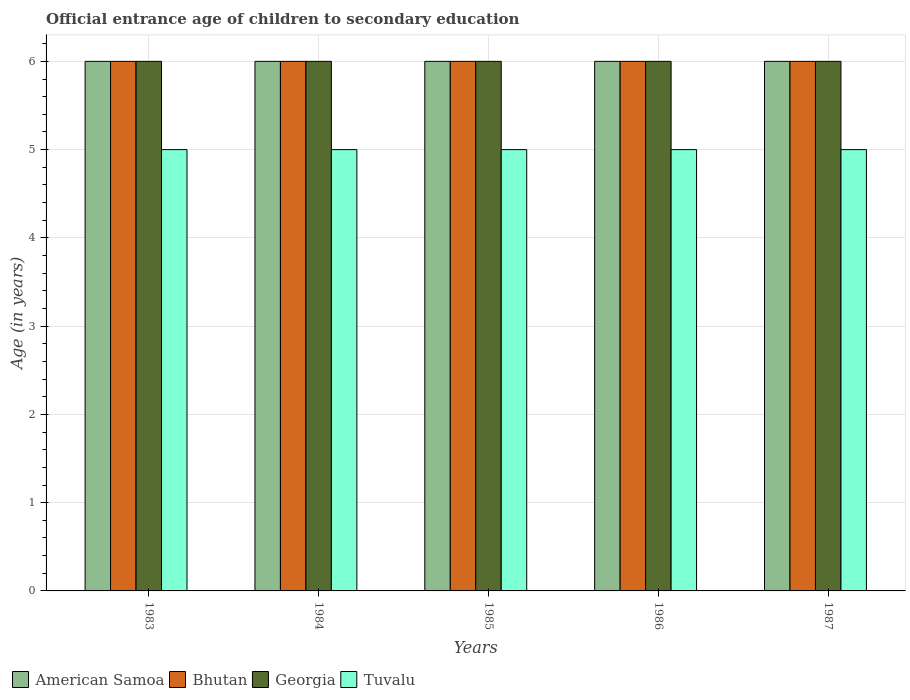How many different coloured bars are there?
Keep it short and to the point. 4. How many groups of bars are there?
Your answer should be compact. 5. What is the label of the 2nd group of bars from the left?
Provide a succinct answer. 1984. Across all years, what is the minimum secondary school starting age of children in Tuvalu?
Your response must be concise. 5. In which year was the secondary school starting age of children in Tuvalu maximum?
Your response must be concise. 1983. What is the total secondary school starting age of children in Georgia in the graph?
Provide a succinct answer. 30. What is the difference between the secondary school starting age of children in Tuvalu in 1983 and that in 1986?
Make the answer very short. 0. What is the average secondary school starting age of children in Bhutan per year?
Your answer should be very brief. 6. In the year 1985, what is the difference between the secondary school starting age of children in Bhutan and secondary school starting age of children in Tuvalu?
Keep it short and to the point. 1. In how many years, is the secondary school starting age of children in Georgia greater than 0.6000000000000001 years?
Offer a terse response. 5. What is the ratio of the secondary school starting age of children in Bhutan in 1985 to that in 1986?
Your answer should be compact. 1. What is the difference between the highest and the second highest secondary school starting age of children in American Samoa?
Your answer should be compact. 0. In how many years, is the secondary school starting age of children in Bhutan greater than the average secondary school starting age of children in Bhutan taken over all years?
Provide a short and direct response. 0. Is the sum of the secondary school starting age of children in Georgia in 1984 and 1986 greater than the maximum secondary school starting age of children in American Samoa across all years?
Your response must be concise. Yes. Is it the case that in every year, the sum of the secondary school starting age of children in American Samoa and secondary school starting age of children in Georgia is greater than the sum of secondary school starting age of children in Bhutan and secondary school starting age of children in Tuvalu?
Provide a short and direct response. Yes. What does the 2nd bar from the left in 1986 represents?
Ensure brevity in your answer.  Bhutan. What does the 1st bar from the right in 1983 represents?
Keep it short and to the point. Tuvalu. Is it the case that in every year, the sum of the secondary school starting age of children in Georgia and secondary school starting age of children in Tuvalu is greater than the secondary school starting age of children in American Samoa?
Your answer should be compact. Yes. How many bars are there?
Offer a very short reply. 20. Does the graph contain grids?
Make the answer very short. Yes. Where does the legend appear in the graph?
Make the answer very short. Bottom left. How many legend labels are there?
Make the answer very short. 4. What is the title of the graph?
Ensure brevity in your answer.  Official entrance age of children to secondary education. Does "Honduras" appear as one of the legend labels in the graph?
Provide a succinct answer. No. What is the label or title of the Y-axis?
Offer a terse response. Age (in years). What is the Age (in years) in American Samoa in 1983?
Provide a short and direct response. 6. What is the Age (in years) of Georgia in 1983?
Your answer should be compact. 6. What is the Age (in years) of Georgia in 1984?
Your response must be concise. 6. What is the Age (in years) in Tuvalu in 1984?
Provide a short and direct response. 5. What is the Age (in years) of Bhutan in 1985?
Give a very brief answer. 6. What is the Age (in years) in Georgia in 1985?
Give a very brief answer. 6. What is the Age (in years) of Bhutan in 1986?
Give a very brief answer. 6. What is the Age (in years) of Georgia in 1986?
Make the answer very short. 6. What is the Age (in years) of Tuvalu in 1986?
Give a very brief answer. 5. What is the Age (in years) in Tuvalu in 1987?
Offer a very short reply. 5. Across all years, what is the maximum Age (in years) of Bhutan?
Make the answer very short. 6. Across all years, what is the maximum Age (in years) of Tuvalu?
Ensure brevity in your answer.  5. Across all years, what is the minimum Age (in years) of Bhutan?
Make the answer very short. 6. What is the total Age (in years) of American Samoa in the graph?
Offer a terse response. 30. What is the total Age (in years) in Georgia in the graph?
Your answer should be compact. 30. What is the total Age (in years) of Tuvalu in the graph?
Your answer should be very brief. 25. What is the difference between the Age (in years) of Georgia in 1983 and that in 1984?
Provide a succinct answer. 0. What is the difference between the Age (in years) in Georgia in 1983 and that in 1985?
Your answer should be compact. 0. What is the difference between the Age (in years) in Tuvalu in 1983 and that in 1985?
Make the answer very short. 0. What is the difference between the Age (in years) in American Samoa in 1983 and that in 1986?
Make the answer very short. 0. What is the difference between the Age (in years) in Bhutan in 1983 and that in 1986?
Your answer should be very brief. 0. What is the difference between the Age (in years) of Georgia in 1983 and that in 1986?
Provide a short and direct response. 0. What is the difference between the Age (in years) in Tuvalu in 1983 and that in 1986?
Give a very brief answer. 0. What is the difference between the Age (in years) of American Samoa in 1983 and that in 1987?
Provide a short and direct response. 0. What is the difference between the Age (in years) in Georgia in 1983 and that in 1987?
Provide a succinct answer. 0. What is the difference between the Age (in years) of American Samoa in 1984 and that in 1985?
Your response must be concise. 0. What is the difference between the Age (in years) of Bhutan in 1984 and that in 1985?
Provide a succinct answer. 0. What is the difference between the Age (in years) of Georgia in 1984 and that in 1985?
Provide a short and direct response. 0. What is the difference between the Age (in years) in American Samoa in 1984 and that in 1986?
Make the answer very short. 0. What is the difference between the Age (in years) of Bhutan in 1984 and that in 1986?
Give a very brief answer. 0. What is the difference between the Age (in years) of Tuvalu in 1984 and that in 1986?
Your answer should be very brief. 0. What is the difference between the Age (in years) in Bhutan in 1984 and that in 1987?
Ensure brevity in your answer.  0. What is the difference between the Age (in years) of American Samoa in 1985 and that in 1986?
Your response must be concise. 0. What is the difference between the Age (in years) in Georgia in 1985 and that in 1986?
Give a very brief answer. 0. What is the difference between the Age (in years) in American Samoa in 1985 and that in 1987?
Ensure brevity in your answer.  0. What is the difference between the Age (in years) of Bhutan in 1985 and that in 1987?
Offer a very short reply. 0. What is the difference between the Age (in years) of Georgia in 1985 and that in 1987?
Offer a very short reply. 0. What is the difference between the Age (in years) of Tuvalu in 1985 and that in 1987?
Offer a terse response. 0. What is the difference between the Age (in years) of Bhutan in 1986 and that in 1987?
Provide a short and direct response. 0. What is the difference between the Age (in years) of Georgia in 1986 and that in 1987?
Offer a terse response. 0. What is the difference between the Age (in years) of American Samoa in 1983 and the Age (in years) of Tuvalu in 1984?
Offer a terse response. 1. What is the difference between the Age (in years) of Bhutan in 1983 and the Age (in years) of Georgia in 1984?
Your answer should be very brief. 0. What is the difference between the Age (in years) of American Samoa in 1983 and the Age (in years) of Georgia in 1985?
Ensure brevity in your answer.  0. What is the difference between the Age (in years) of American Samoa in 1983 and the Age (in years) of Tuvalu in 1985?
Make the answer very short. 1. What is the difference between the Age (in years) in American Samoa in 1983 and the Age (in years) in Tuvalu in 1986?
Your answer should be compact. 1. What is the difference between the Age (in years) in Georgia in 1983 and the Age (in years) in Tuvalu in 1986?
Ensure brevity in your answer.  1. What is the difference between the Age (in years) of American Samoa in 1983 and the Age (in years) of Georgia in 1987?
Keep it short and to the point. 0. What is the difference between the Age (in years) in American Samoa in 1983 and the Age (in years) in Tuvalu in 1987?
Provide a short and direct response. 1. What is the difference between the Age (in years) in Georgia in 1983 and the Age (in years) in Tuvalu in 1987?
Give a very brief answer. 1. What is the difference between the Age (in years) in American Samoa in 1984 and the Age (in years) in Georgia in 1985?
Make the answer very short. 0. What is the difference between the Age (in years) of Bhutan in 1984 and the Age (in years) of Tuvalu in 1985?
Provide a succinct answer. 1. What is the difference between the Age (in years) in Georgia in 1984 and the Age (in years) in Tuvalu in 1985?
Offer a terse response. 1. What is the difference between the Age (in years) of American Samoa in 1984 and the Age (in years) of Bhutan in 1986?
Provide a succinct answer. 0. What is the difference between the Age (in years) in American Samoa in 1984 and the Age (in years) in Georgia in 1986?
Provide a succinct answer. 0. What is the difference between the Age (in years) of Bhutan in 1984 and the Age (in years) of Tuvalu in 1986?
Keep it short and to the point. 1. What is the difference between the Age (in years) of Bhutan in 1984 and the Age (in years) of Georgia in 1987?
Ensure brevity in your answer.  0. What is the difference between the Age (in years) in Bhutan in 1984 and the Age (in years) in Tuvalu in 1987?
Provide a succinct answer. 1. What is the difference between the Age (in years) of Georgia in 1984 and the Age (in years) of Tuvalu in 1987?
Ensure brevity in your answer.  1. What is the difference between the Age (in years) of American Samoa in 1985 and the Age (in years) of Tuvalu in 1986?
Offer a very short reply. 1. What is the difference between the Age (in years) in Bhutan in 1985 and the Age (in years) in Tuvalu in 1986?
Provide a short and direct response. 1. What is the difference between the Age (in years) in American Samoa in 1985 and the Age (in years) in Bhutan in 1987?
Ensure brevity in your answer.  0. What is the difference between the Age (in years) in Bhutan in 1985 and the Age (in years) in Georgia in 1987?
Your answer should be compact. 0. What is the difference between the Age (in years) of Bhutan in 1985 and the Age (in years) of Tuvalu in 1987?
Ensure brevity in your answer.  1. What is the difference between the Age (in years) of American Samoa in 1986 and the Age (in years) of Bhutan in 1987?
Give a very brief answer. 0. What is the difference between the Age (in years) of American Samoa in 1986 and the Age (in years) of Tuvalu in 1987?
Your answer should be very brief. 1. What is the difference between the Age (in years) of Bhutan in 1986 and the Age (in years) of Georgia in 1987?
Keep it short and to the point. 0. What is the difference between the Age (in years) of Bhutan in 1986 and the Age (in years) of Tuvalu in 1987?
Offer a terse response. 1. What is the difference between the Age (in years) of Georgia in 1986 and the Age (in years) of Tuvalu in 1987?
Give a very brief answer. 1. What is the average Age (in years) in Tuvalu per year?
Your answer should be very brief. 5. In the year 1983, what is the difference between the Age (in years) of American Samoa and Age (in years) of Georgia?
Offer a very short reply. 0. In the year 1983, what is the difference between the Age (in years) of American Samoa and Age (in years) of Tuvalu?
Your answer should be very brief. 1. In the year 1984, what is the difference between the Age (in years) of American Samoa and Age (in years) of Bhutan?
Your answer should be very brief. 0. In the year 1984, what is the difference between the Age (in years) in American Samoa and Age (in years) in Georgia?
Give a very brief answer. 0. In the year 1984, what is the difference between the Age (in years) in Bhutan and Age (in years) in Georgia?
Offer a terse response. 0. In the year 1984, what is the difference between the Age (in years) in Bhutan and Age (in years) in Tuvalu?
Offer a terse response. 1. In the year 1985, what is the difference between the Age (in years) of American Samoa and Age (in years) of Georgia?
Ensure brevity in your answer.  0. In the year 1985, what is the difference between the Age (in years) in American Samoa and Age (in years) in Tuvalu?
Your answer should be very brief. 1. In the year 1985, what is the difference between the Age (in years) in Bhutan and Age (in years) in Georgia?
Make the answer very short. 0. In the year 1986, what is the difference between the Age (in years) in American Samoa and Age (in years) in Bhutan?
Ensure brevity in your answer.  0. In the year 1986, what is the difference between the Age (in years) of American Samoa and Age (in years) of Georgia?
Give a very brief answer. 0. In the year 1986, what is the difference between the Age (in years) in Georgia and Age (in years) in Tuvalu?
Offer a terse response. 1. In the year 1987, what is the difference between the Age (in years) in American Samoa and Age (in years) in Tuvalu?
Offer a very short reply. 1. In the year 1987, what is the difference between the Age (in years) in Bhutan and Age (in years) in Tuvalu?
Your answer should be very brief. 1. What is the ratio of the Age (in years) in American Samoa in 1983 to that in 1984?
Keep it short and to the point. 1. What is the ratio of the Age (in years) in Bhutan in 1983 to that in 1984?
Your answer should be compact. 1. What is the ratio of the Age (in years) of Georgia in 1983 to that in 1984?
Ensure brevity in your answer.  1. What is the ratio of the Age (in years) of Tuvalu in 1983 to that in 1984?
Offer a terse response. 1. What is the ratio of the Age (in years) of American Samoa in 1983 to that in 1985?
Make the answer very short. 1. What is the ratio of the Age (in years) in Bhutan in 1983 to that in 1985?
Provide a short and direct response. 1. What is the ratio of the Age (in years) of Georgia in 1983 to that in 1985?
Provide a succinct answer. 1. What is the ratio of the Age (in years) of Tuvalu in 1983 to that in 1985?
Keep it short and to the point. 1. What is the ratio of the Age (in years) in American Samoa in 1983 to that in 1986?
Offer a terse response. 1. What is the ratio of the Age (in years) in Bhutan in 1983 to that in 1986?
Your response must be concise. 1. What is the ratio of the Age (in years) of Tuvalu in 1983 to that in 1986?
Give a very brief answer. 1. What is the ratio of the Age (in years) of Bhutan in 1983 to that in 1987?
Your response must be concise. 1. What is the ratio of the Age (in years) of Tuvalu in 1983 to that in 1987?
Your answer should be compact. 1. What is the ratio of the Age (in years) in American Samoa in 1984 to that in 1985?
Your response must be concise. 1. What is the ratio of the Age (in years) in Tuvalu in 1984 to that in 1985?
Offer a very short reply. 1. What is the ratio of the Age (in years) of American Samoa in 1984 to that in 1986?
Your response must be concise. 1. What is the ratio of the Age (in years) in Georgia in 1984 to that in 1986?
Keep it short and to the point. 1. What is the ratio of the Age (in years) of Tuvalu in 1984 to that in 1986?
Make the answer very short. 1. What is the ratio of the Age (in years) of American Samoa in 1984 to that in 1987?
Provide a short and direct response. 1. What is the ratio of the Age (in years) of American Samoa in 1985 to that in 1986?
Offer a terse response. 1. What is the ratio of the Age (in years) in Bhutan in 1985 to that in 1986?
Provide a short and direct response. 1. What is the ratio of the Age (in years) of Georgia in 1985 to that in 1986?
Give a very brief answer. 1. What is the ratio of the Age (in years) of American Samoa in 1985 to that in 1987?
Keep it short and to the point. 1. What is the ratio of the Age (in years) of Georgia in 1985 to that in 1987?
Ensure brevity in your answer.  1. What is the ratio of the Age (in years) of Tuvalu in 1985 to that in 1987?
Your response must be concise. 1. What is the ratio of the Age (in years) in American Samoa in 1986 to that in 1987?
Your answer should be very brief. 1. What is the ratio of the Age (in years) of Bhutan in 1986 to that in 1987?
Give a very brief answer. 1. What is the ratio of the Age (in years) of Georgia in 1986 to that in 1987?
Your answer should be very brief. 1. What is the ratio of the Age (in years) in Tuvalu in 1986 to that in 1987?
Your answer should be very brief. 1. What is the difference between the highest and the lowest Age (in years) of Tuvalu?
Keep it short and to the point. 0. 